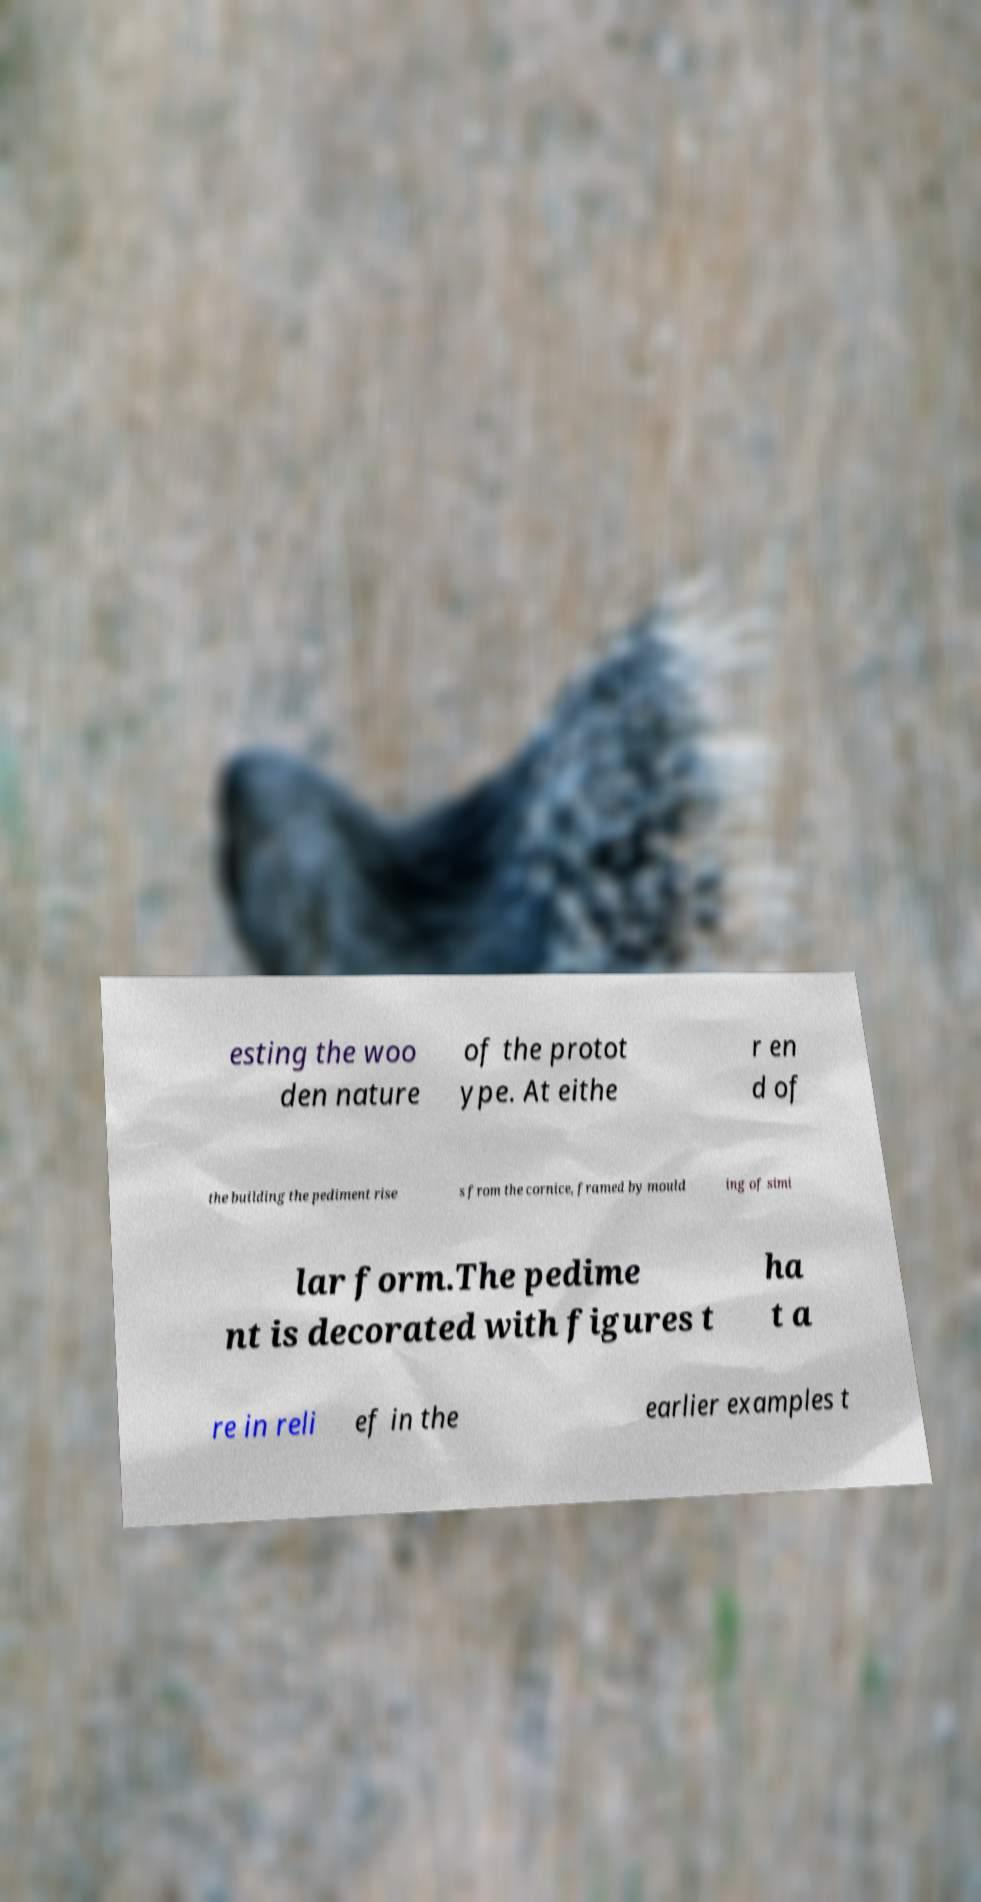Could you extract and type out the text from this image? esting the woo den nature of the protot ype. At eithe r en d of the building the pediment rise s from the cornice, framed by mould ing of simi lar form.The pedime nt is decorated with figures t ha t a re in reli ef in the earlier examples t 